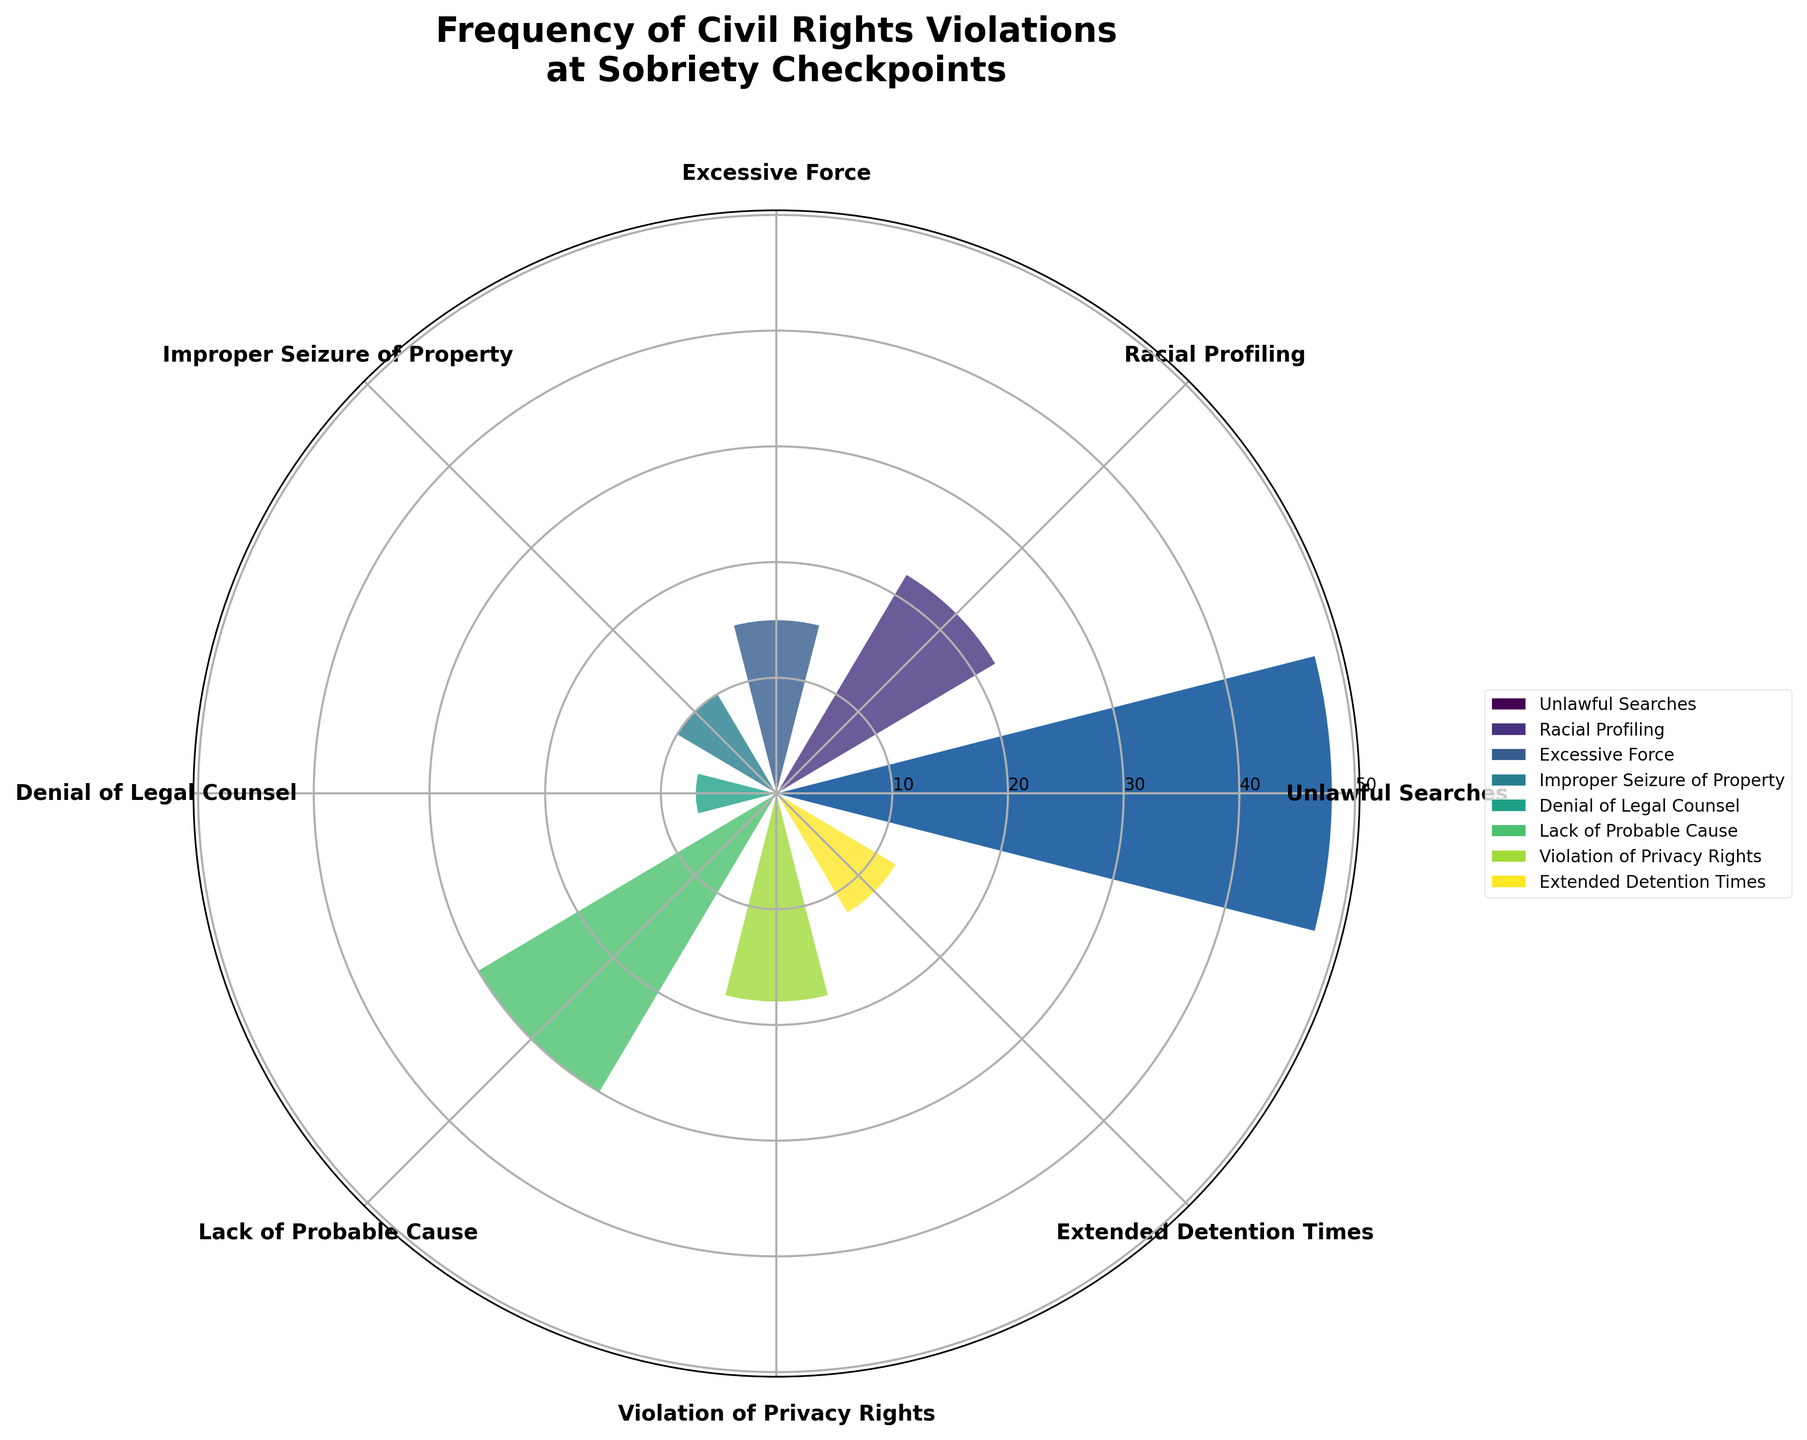what is the title of this figure? The title of a figure is typically displayed at the top and helps to summarize the content of the plot. In this figure, the title is given as “Frequency of Civil Rights Violations at Sobriety Checkpoints."
Answer: Frequency of Civil Rights Violations at Sobriety Checkpoints Which type of violation has the highest frequency? To determine the highest frequency violation, look for the longest bar in the polar area chart. Here, "Unlawful Searches" extends the most outward, representing the highest frequency.
Answer: Unlawful Searches How many types of civil rights violations are reported? Count the number of distinct categories mentioned around the polar plot. Each category represents a type of violation. There are eight types of violations listed.
Answer: Eight What is the frequency of denial of legal counsel violations? Find the section labeled "Denial of Legal Counsel" on the polar area chart, and note the number it extends to on the frequency scale.
Answer: Seven What is the combined frequency of improper seizure of property and extended detention times violations? Locate the bars for "Improper Seizure of Property" and "Extended Detention Times," note their frequencies (10 and 12), and then add them together (10 + 12 = 22).
Answer: 22 Which type of violation is less frequent, racial profiling or lack of probable cause? Compare the lengths of the bars for "Racial Profiling" and "Lack of Probable Cause." "Racial Profiling" has a shorter bar, indicating a lower frequency compared to "Lack of Probable Cause."
Answer: Racial Profiling What is the difference in frequency between unlawful searches and excessive force violations? Identify the frequencies for "Unlawful Searches" (48) and "Excessive Force" (15). Subtract the smaller number from the larger number (48 - 15 = 33).
Answer: 33 What is the average frequency of reported civil rights violations? Add up all the frequencies (48 + 22 + 15 + 10 + 7 + 30 + 18 + 12 = 162) and divide by the number of violation types (8). The average is 162 / 8 = 20.25.
Answer: 20.25 Which violation frequency is closest to the median value? List all frequencies in ascending order: 7, 10, 12, 15, 18, 22, 30, 48. The median is the middle value of a sorted list. Here, the middle pair (15 and 18) averaged is the median value (16.5). "Violation of Privacy Rights" at 18 is closest to 16.5.
Answer: Violation of Privacy Rights 